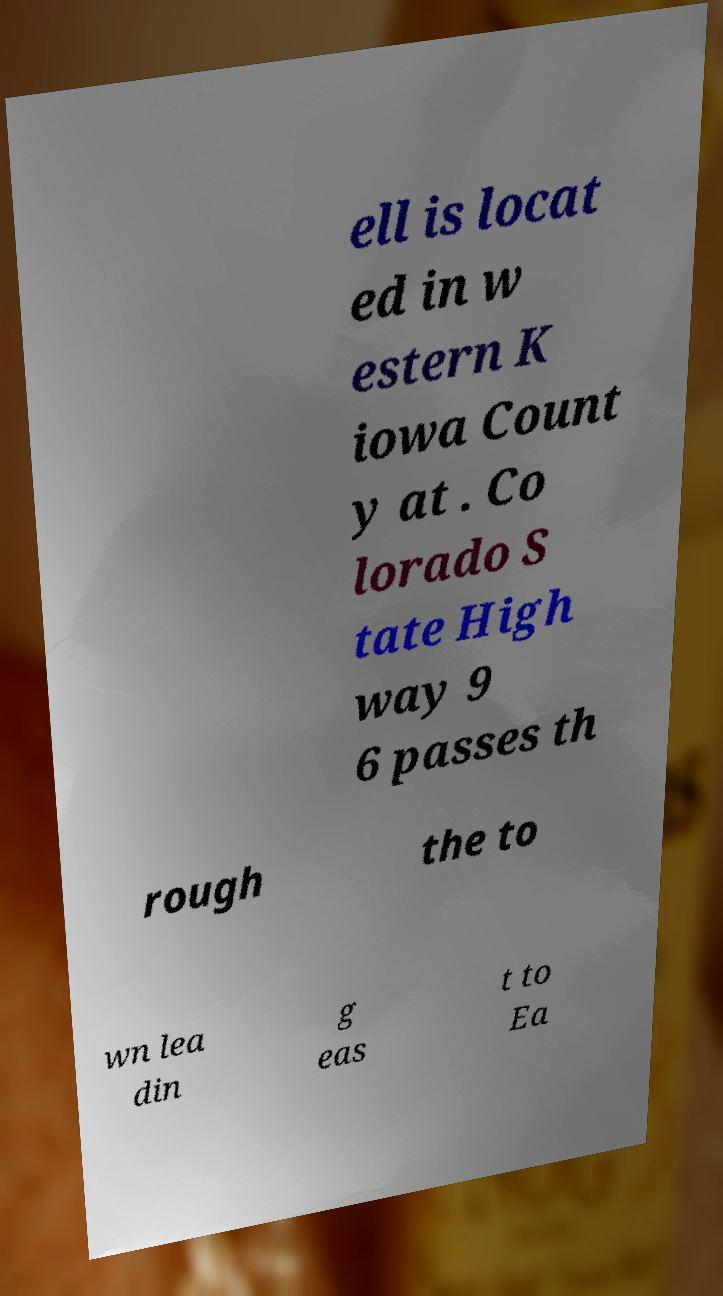There's text embedded in this image that I need extracted. Can you transcribe it verbatim? ell is locat ed in w estern K iowa Count y at . Co lorado S tate High way 9 6 passes th rough the to wn lea din g eas t to Ea 